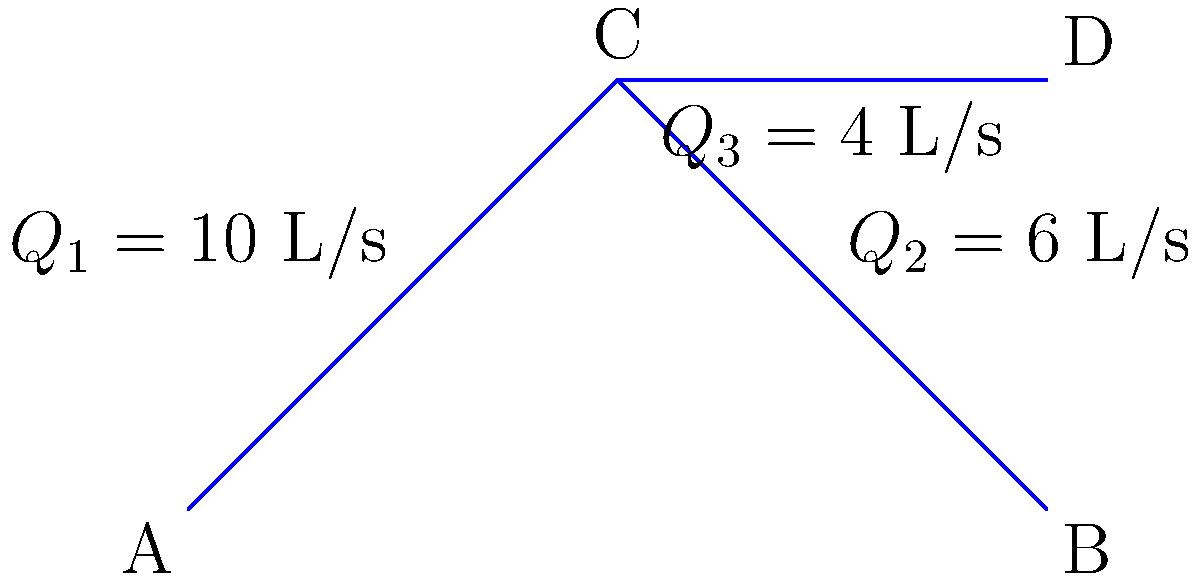In this groovy pipe network, we've got a funky flow situation. At point A, water's rockin' at 10 L/s, then it splits at junction C. If 4 L/s is groovin' to point D, what's the righteous flow rate cruisin' to point B? Let's jam on this hydraulic harmony! Alright, let's break down this flow like we're dissecting a complex chord progression:

1) First, we need to understand the principle of conservation of mass in fluid mechanics. It's like keeping the beat in a song - what comes in must go out.

2) At point A, we have the total flow rate entering the system:
   $Q_1 = 10$ L/s

3) This flow splits at junction C into two branches:
   - One branch goes to point D with flow rate $Q_3 = 4$ L/s
   - The other branch goes to point B, let's call this unknown flow rate $Q_2$

4) According to the conservation of mass principle:
   $Q_1 = Q_2 + Q_3$

5) We can now solve for $Q_2$:
   $Q_2 = Q_1 - Q_3$
   $Q_2 = 10 \text{ L/s} - 4 \text{ L/s}$
   $Q_2 = 6 \text{ L/s}$

So, the flow rate cruising to point B is 6 L/s. It's like the water is splitting into a duet, with the main melody (6 L/s) heading to B and a harmony (4 L/s) flowing to D.
Answer: 6 L/s 